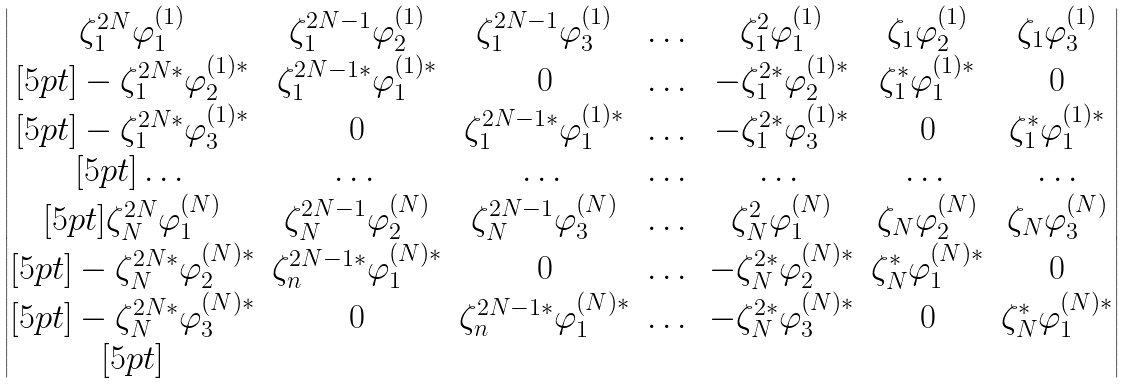<formula> <loc_0><loc_0><loc_500><loc_500>\begin{vmatrix} \zeta _ { 1 } ^ { 2 N } \varphi _ { 1 } ^ { ( 1 ) } & \zeta _ { 1 } ^ { 2 N - 1 } \varphi _ { 2 } ^ { ( 1 ) } & \zeta _ { 1 } ^ { 2 N - 1 } \varphi _ { 3 } ^ { ( 1 ) } & \dots & \zeta _ { 1 } ^ { 2 } \varphi _ { 1 } ^ { ( 1 ) } & \zeta _ { 1 } \varphi _ { 2 } ^ { ( 1 ) } & \zeta _ { 1 } \varphi _ { 3 } ^ { ( 1 ) } \\ [ 5 p t ] - \zeta _ { 1 } ^ { 2 N * } \varphi _ { 2 } ^ { ( 1 ) * } & \zeta _ { 1 } ^ { 2 N - 1 * } \varphi _ { 1 } ^ { ( 1 ) * } & 0 & \dots & - \zeta _ { 1 } ^ { 2 * } \varphi _ { 2 } ^ { ( 1 ) * } & \zeta _ { 1 } ^ { * } \varphi _ { 1 } ^ { ( 1 ) * } & 0 \\ [ 5 p t ] - \zeta _ { 1 } ^ { 2 N * } \varphi _ { 3 } ^ { ( 1 ) * } & 0 & \zeta _ { 1 } ^ { 2 N - 1 * } \varphi _ { 1 } ^ { ( 1 ) * } & \dots & - \zeta _ { 1 } ^ { 2 * } \varphi _ { 3 } ^ { ( 1 ) * } & 0 & \zeta _ { 1 } ^ { * } \varphi _ { 1 } ^ { ( 1 ) * } \\ [ 5 p t ] \dots & \dots & \dots & \dots & \dots & \dots & \dots \\ [ 5 p t ] \zeta _ { N } ^ { 2 N } \varphi _ { 1 } ^ { ( N ) } & \zeta _ { N } ^ { 2 N - 1 } \varphi _ { 2 } ^ { ( N ) } & \zeta _ { N } ^ { 2 N - 1 } \varphi _ { 3 } ^ { ( N ) } & \dots & \zeta _ { N } ^ { 2 } \varphi _ { 1 } ^ { ( N ) } & \zeta _ { N } \varphi _ { 2 } ^ { ( N ) } & \zeta _ { N } \varphi _ { 3 } ^ { ( N ) } \\ [ 5 p t ] - \zeta _ { N } ^ { 2 N * } \varphi _ { 2 } ^ { ( N ) * } & \zeta _ { n } ^ { 2 N - 1 * } \varphi _ { 1 } ^ { ( N ) * } & 0 & \dots & - \zeta _ { N } ^ { 2 * } \varphi _ { 2 } ^ { ( N ) * } & \zeta _ { N } ^ { * } \varphi _ { 1 } ^ { ( N ) * } & 0 \\ [ 5 p t ] - \zeta _ { N } ^ { 2 N * } \varphi _ { 3 } ^ { ( N ) * } & 0 & \zeta _ { n } ^ { 2 N - 1 * } \varphi _ { 1 } ^ { ( N ) * } & \dots & - \zeta _ { N } ^ { 2 * } \varphi _ { 3 } ^ { ( N ) * } & 0 & \zeta _ { N } ^ { * } \varphi _ { 1 } ^ { ( N ) * } \\ [ 5 p t ] \end{vmatrix}</formula> 